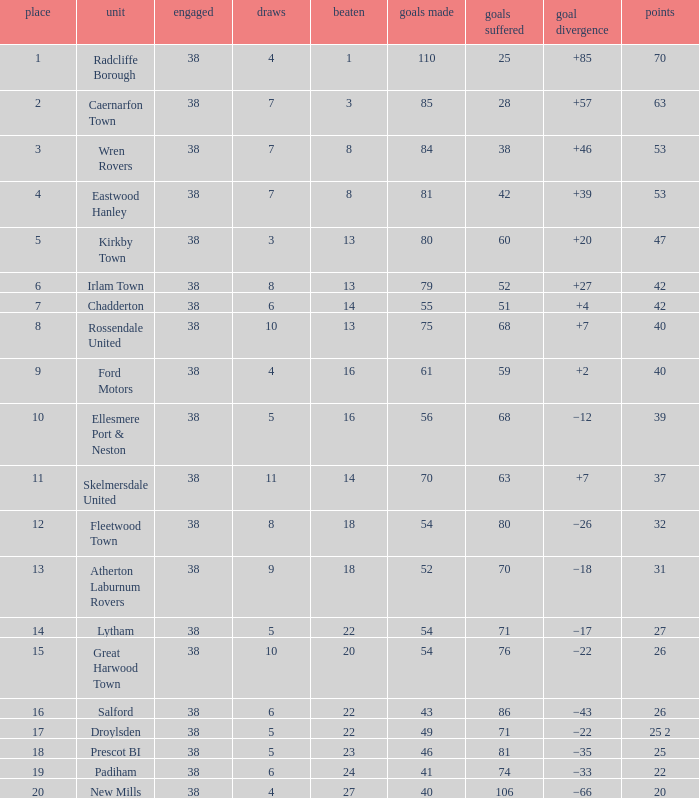Which Played has a Drawn of 4, and a Position of 9, and Goals Against larger than 59? None. 